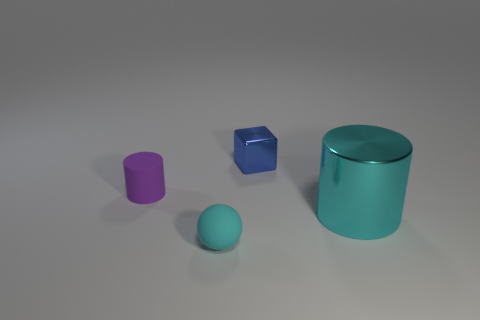Add 4 tiny brown metal cylinders. How many objects exist? 8 Subtract all balls. How many objects are left? 3 Add 3 blocks. How many blocks are left? 4 Add 1 red shiny balls. How many red shiny balls exist? 1 Subtract 0 yellow spheres. How many objects are left? 4 Subtract all tiny cyan matte spheres. Subtract all tiny blue metal cubes. How many objects are left? 2 